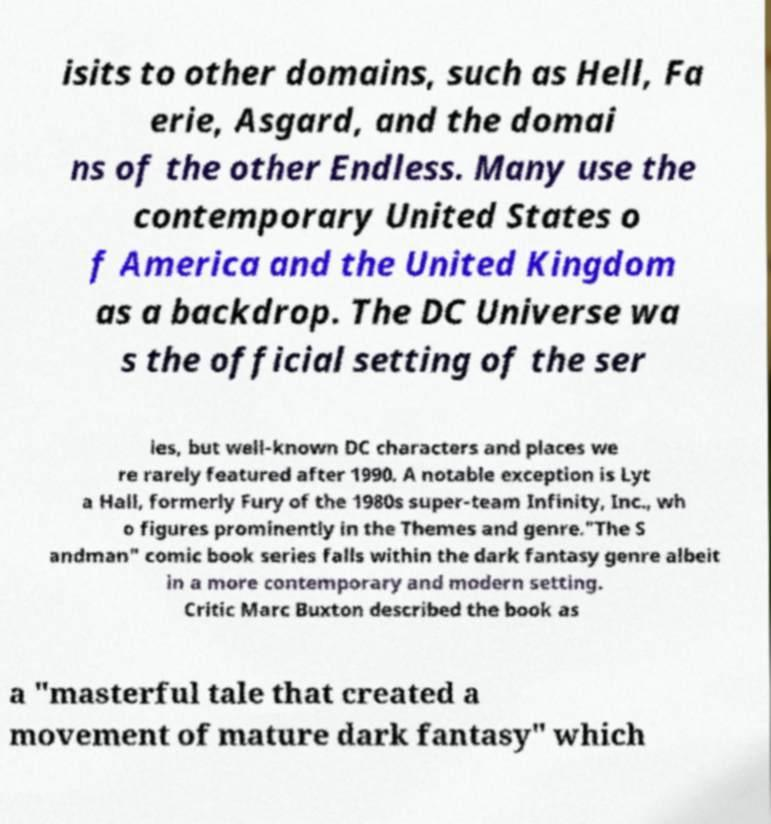I need the written content from this picture converted into text. Can you do that? isits to other domains, such as Hell, Fa erie, Asgard, and the domai ns of the other Endless. Many use the contemporary United States o f America and the United Kingdom as a backdrop. The DC Universe wa s the official setting of the ser ies, but well-known DC characters and places we re rarely featured after 1990. A notable exception is Lyt a Hall, formerly Fury of the 1980s super-team Infinity, Inc., wh o figures prominently in the Themes and genre."The S andman" comic book series falls within the dark fantasy genre albeit in a more contemporary and modern setting. Critic Marc Buxton described the book as a "masterful tale that created a movement of mature dark fantasy" which 